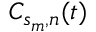<formula> <loc_0><loc_0><loc_500><loc_500>C _ { s _ { m } , n } ( t )</formula> 